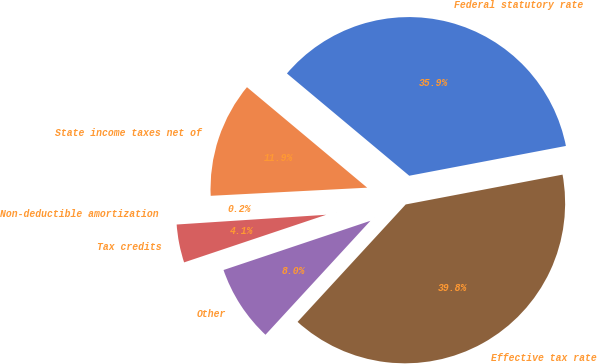Convert chart. <chart><loc_0><loc_0><loc_500><loc_500><pie_chart><fcel>Federal statutory rate<fcel>State income taxes net of<fcel>Non-deductible amortization<fcel>Tax credits<fcel>Other<fcel>Effective tax rate<nl><fcel>35.93%<fcel>11.91%<fcel>0.21%<fcel>4.11%<fcel>8.01%<fcel>39.84%<nl></chart> 